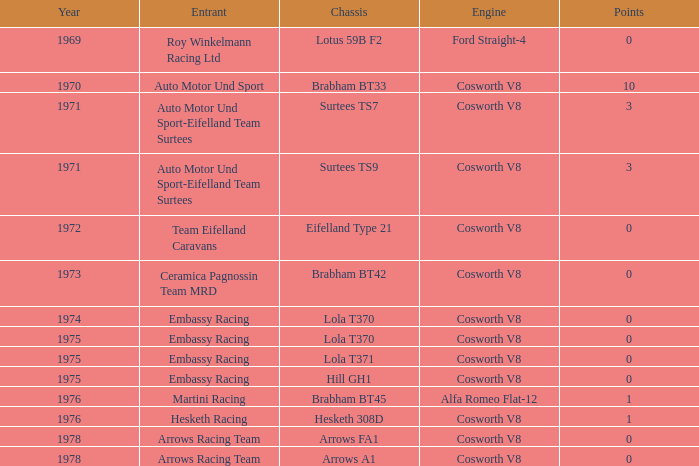Who was the entrant in 1971? Auto Motor Und Sport-Eifelland Team Surtees, Auto Motor Und Sport-Eifelland Team Surtees. 